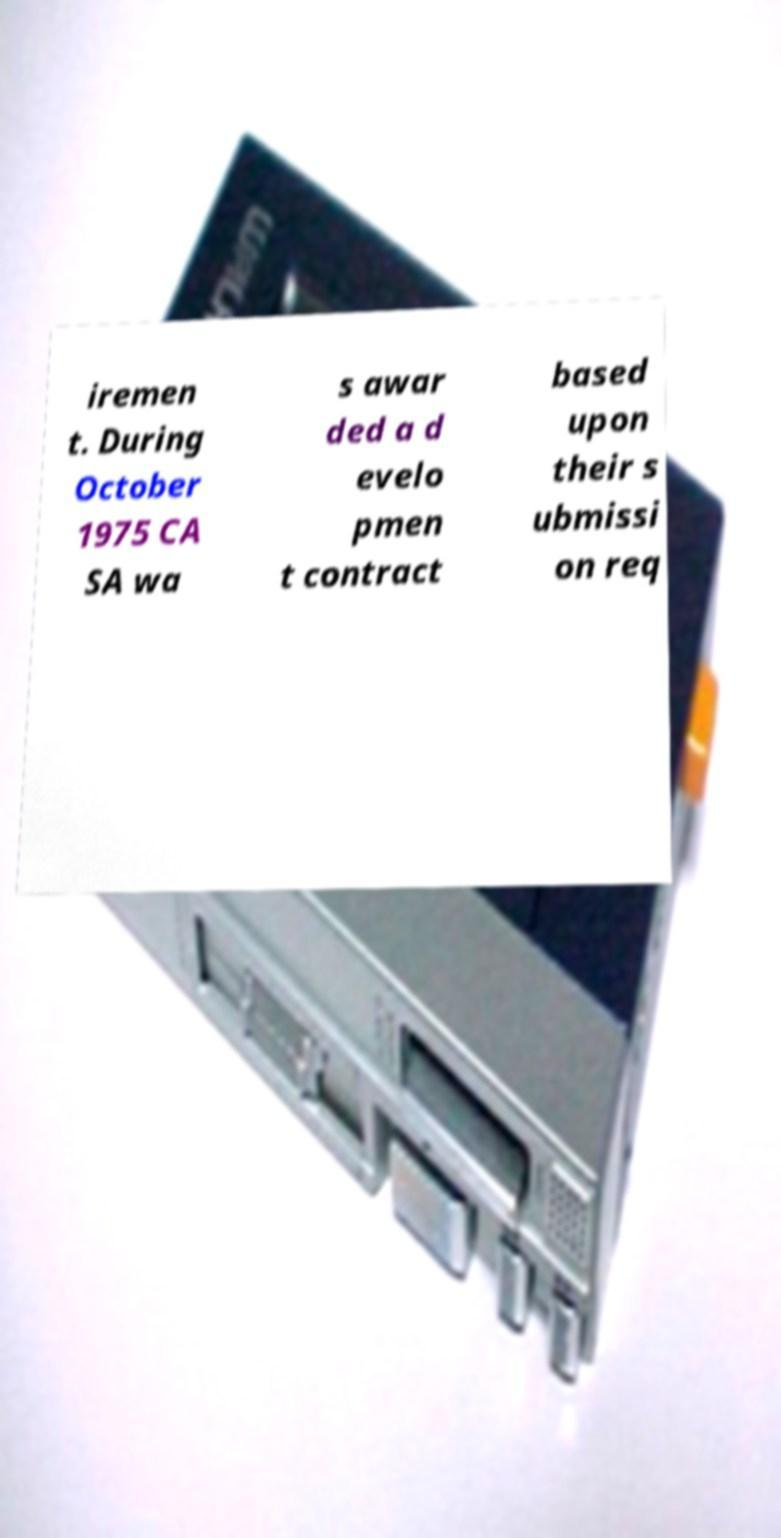What messages or text are displayed in this image? I need them in a readable, typed format. iremen t. During October 1975 CA SA wa s awar ded a d evelo pmen t contract based upon their s ubmissi on req 